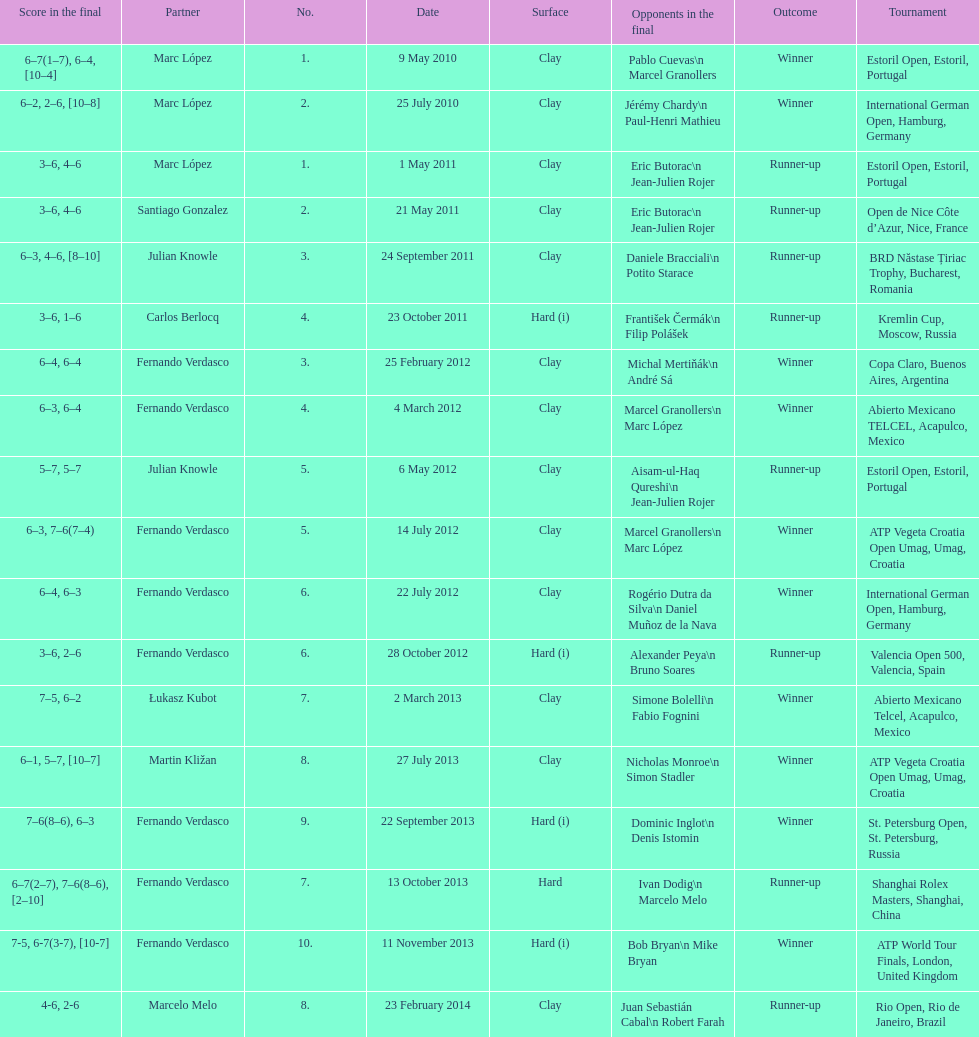How many tournaments has this player won in his career so far? 10. 